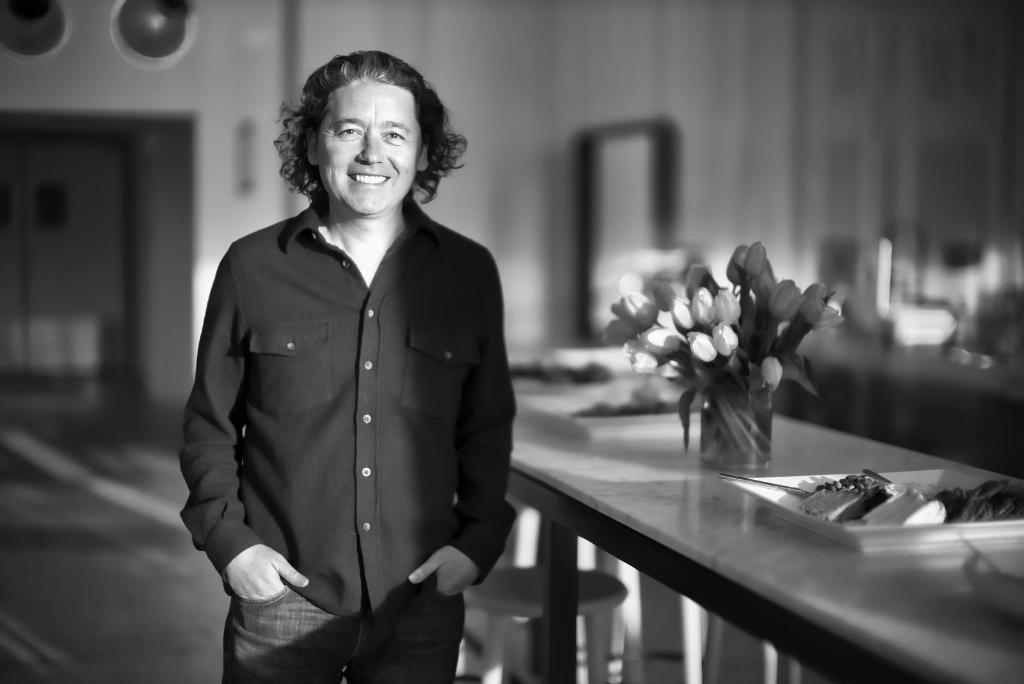In one or two sentences, can you explain what this image depicts? This is a black and white image where a man is standing in black dress having smile on his face. On the right side of the image, there is a table with flower vase and a platter on it. In the background, there is a wall and a door. 